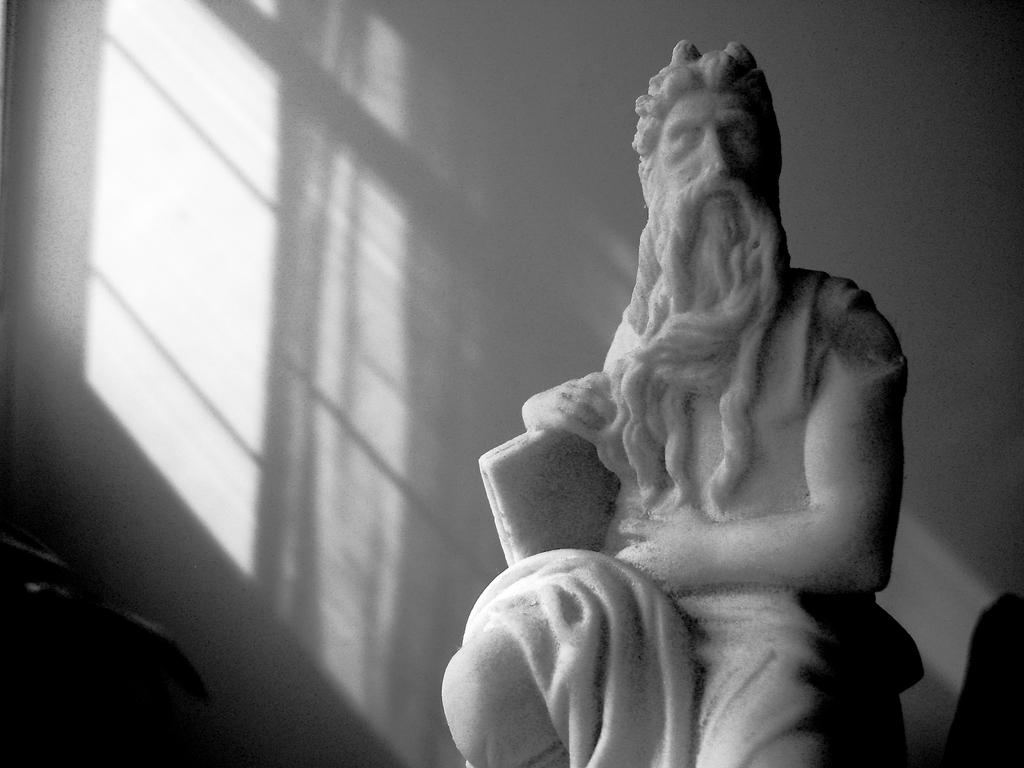What is the main subject of the image? There is a sculpture of a person in the image. Can you describe the setting of the image? There is a wall in the background of the image. What type of trousers is the sculpture wearing in the image? The sculpture does not have trousers, as it is a sculpture and not a living person. 